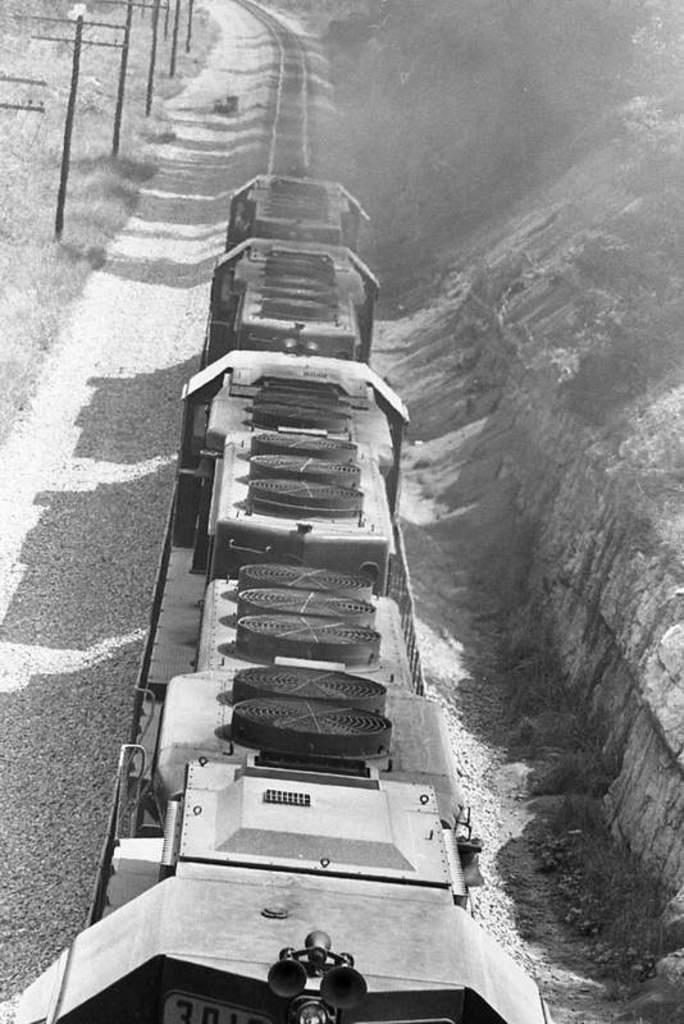Could you give a brief overview of what you see in this image? This is a black and white picture, there is train in the middle with grassland on either side of it. 